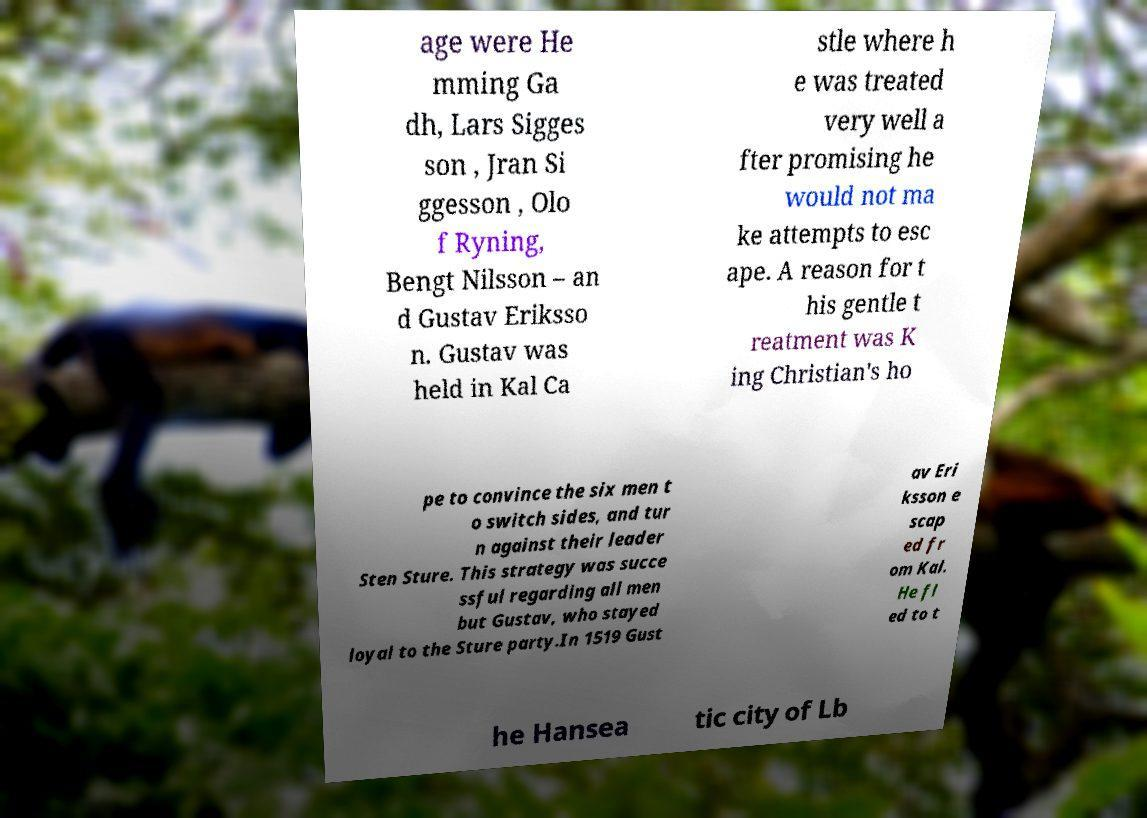Please read and relay the text visible in this image. What does it say? age were He mming Ga dh, Lars Sigges son , Jran Si ggesson , Olo f Ryning, Bengt Nilsson – an d Gustav Eriksso n. Gustav was held in Kal Ca stle where h e was treated very well a fter promising he would not ma ke attempts to esc ape. A reason for t his gentle t reatment was K ing Christian's ho pe to convince the six men t o switch sides, and tur n against their leader Sten Sture. This strategy was succe ssful regarding all men but Gustav, who stayed loyal to the Sture party.In 1519 Gust av Eri ksson e scap ed fr om Kal. He fl ed to t he Hansea tic city of Lb 